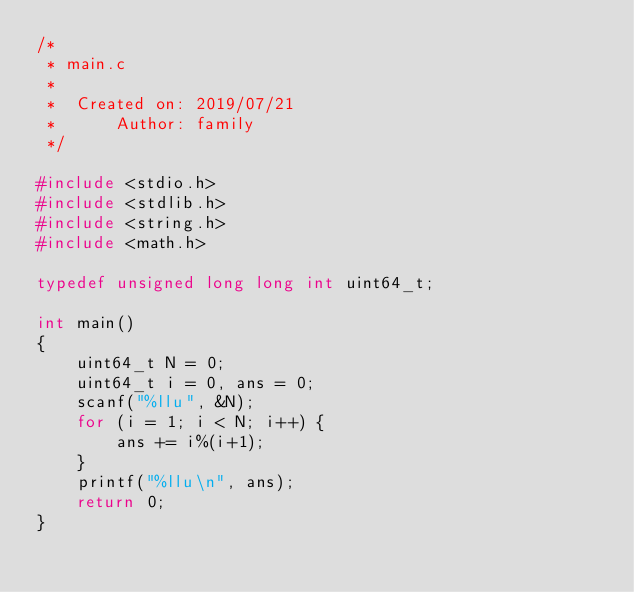Convert code to text. <code><loc_0><loc_0><loc_500><loc_500><_C_>/*
 * main.c
 *
 *  Created on: 2019/07/21
 *      Author: family
 */

#include <stdio.h>
#include <stdlib.h>
#include <string.h>
#include <math.h>

typedef unsigned long long int uint64_t;

int main()
{
	uint64_t N = 0;
	uint64_t i = 0, ans = 0;
	scanf("%llu", &N);
	for (i = 1; i < N; i++) {
		ans += i%(i+1);
	}
	printf("%llu\n", ans);
    return 0;
}
</code> 